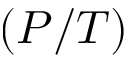Convert formula to latex. <formula><loc_0><loc_0><loc_500><loc_500>( P / T )</formula> 